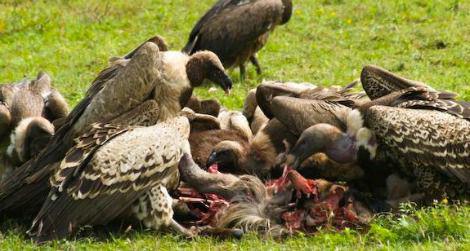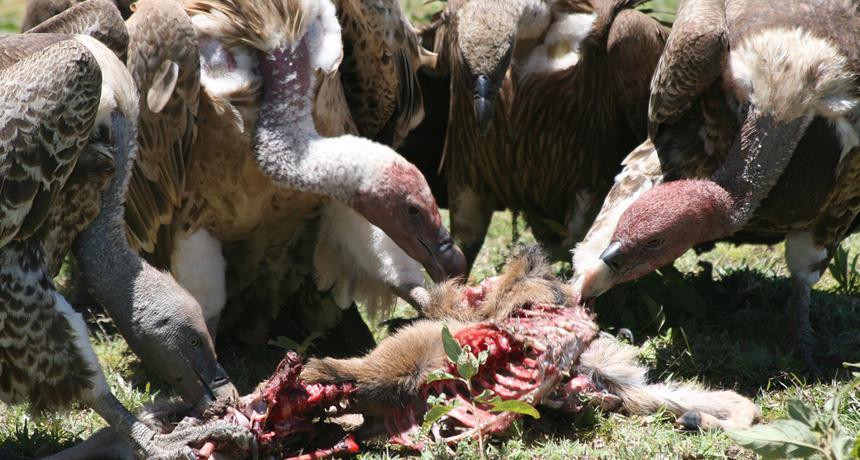The first image is the image on the left, the second image is the image on the right. Analyze the images presented: Is the assertion "There is a human skeleton next to a group of vultures in one of the images." valid? Answer yes or no. No. The first image is the image on the left, the second image is the image on the right. Given the left and right images, does the statement "In every image, the vultures are eating." hold true? Answer yes or no. Yes. 